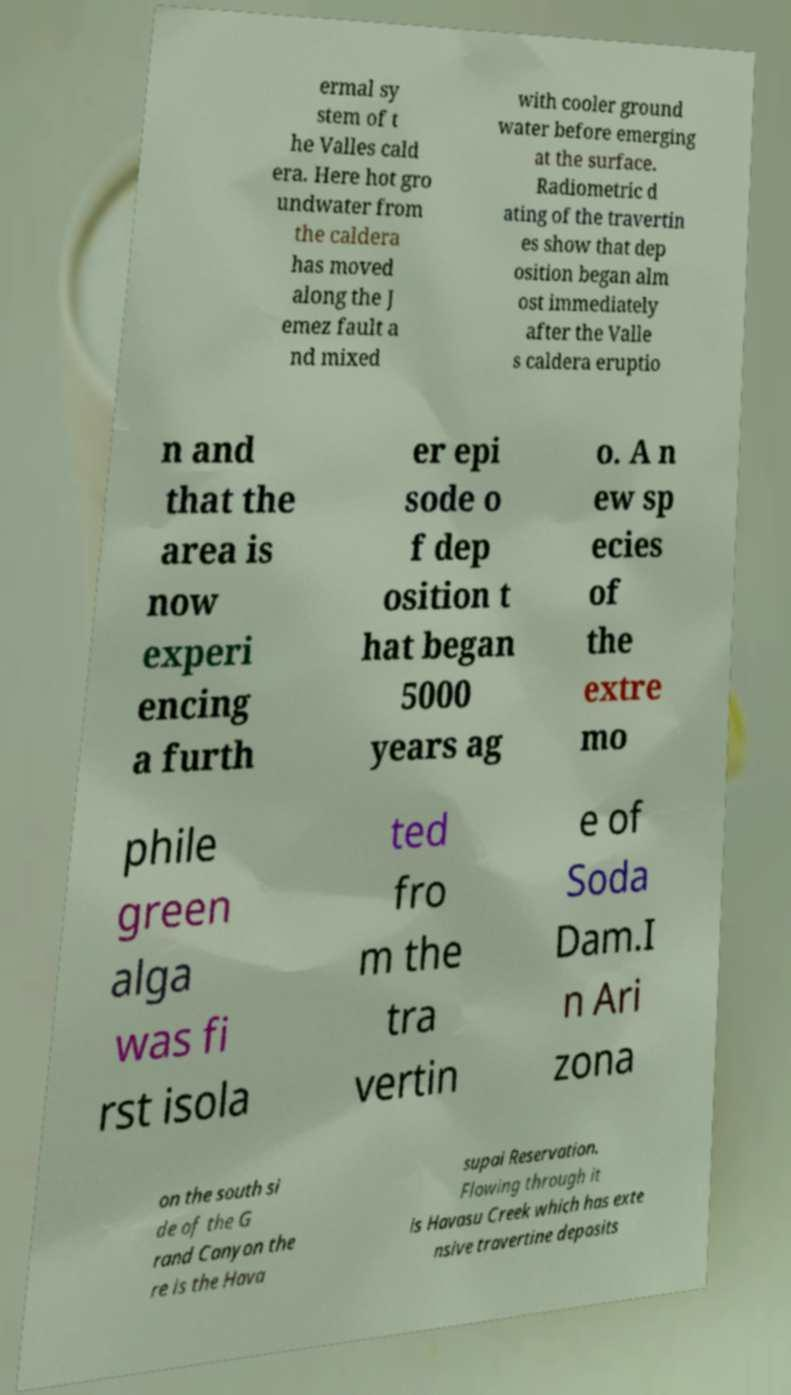For documentation purposes, I need the text within this image transcribed. Could you provide that? ermal sy stem of t he Valles cald era. Here hot gro undwater from the caldera has moved along the J emez fault a nd mixed with cooler ground water before emerging at the surface. Radiometric d ating of the travertin es show that dep osition began alm ost immediately after the Valle s caldera eruptio n and that the area is now experi encing a furth er epi sode o f dep osition t hat began 5000 years ag o. A n ew sp ecies of the extre mo phile green alga was fi rst isola ted fro m the tra vertin e of Soda Dam.I n Ari zona on the south si de of the G rand Canyon the re is the Hava supai Reservation. Flowing through it is Havasu Creek which has exte nsive travertine deposits 